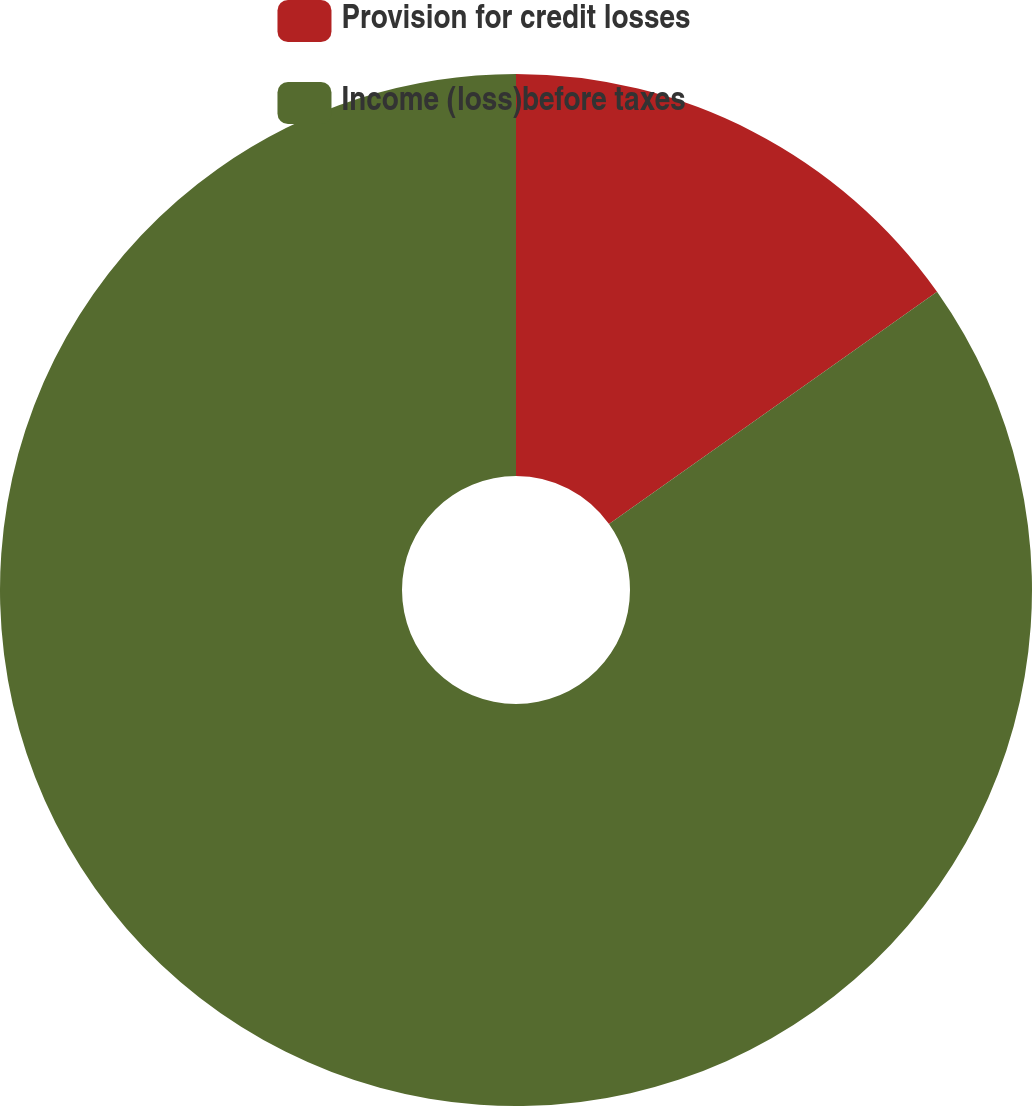<chart> <loc_0><loc_0><loc_500><loc_500><pie_chart><fcel>Provision for credit losses<fcel>Income (loss)before taxes<nl><fcel>15.19%<fcel>84.81%<nl></chart> 